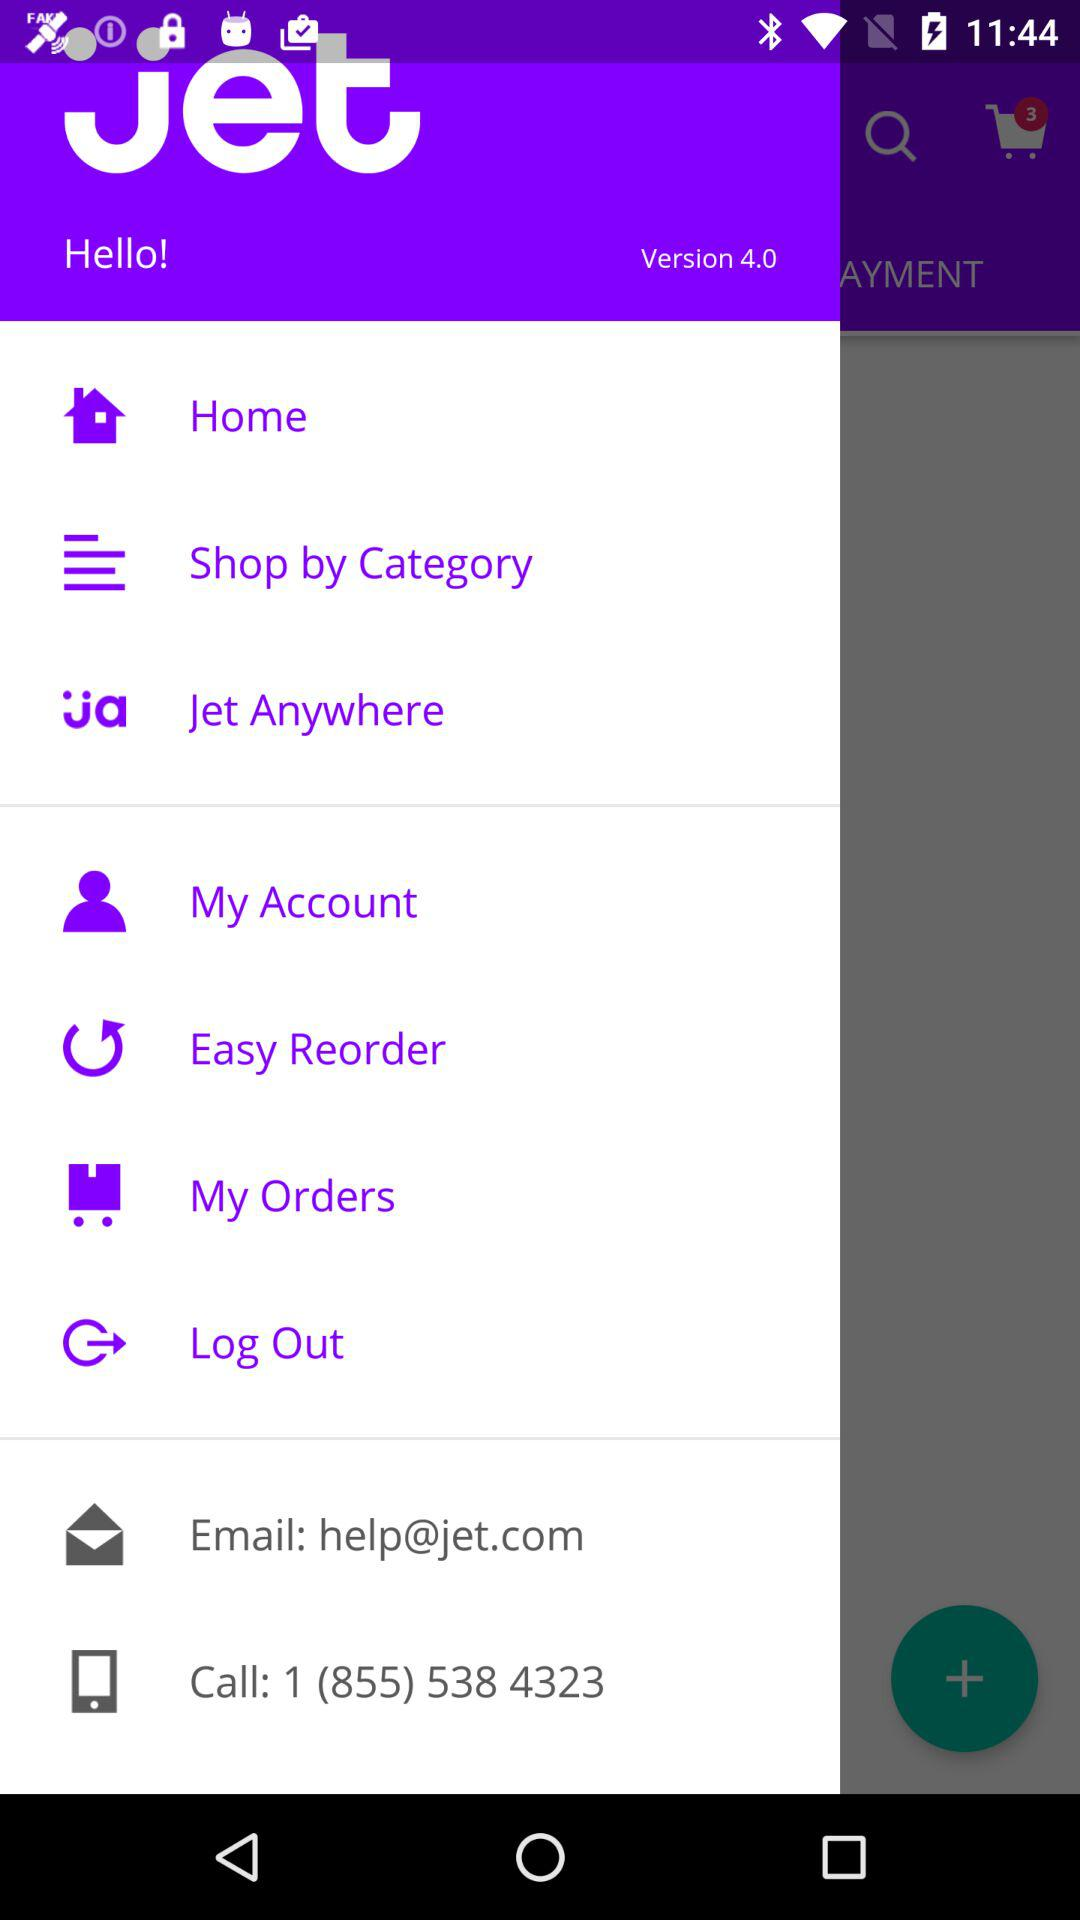What is the name of the application? The name of the application is "Jet". 